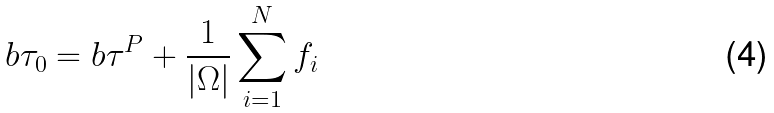Convert formula to latex. <formula><loc_0><loc_0><loc_500><loc_500>b \tau _ { 0 } = b \tau ^ { P } + \frac { 1 } { | \Omega | } \sum _ { i = 1 } ^ { N } f _ { i }</formula> 